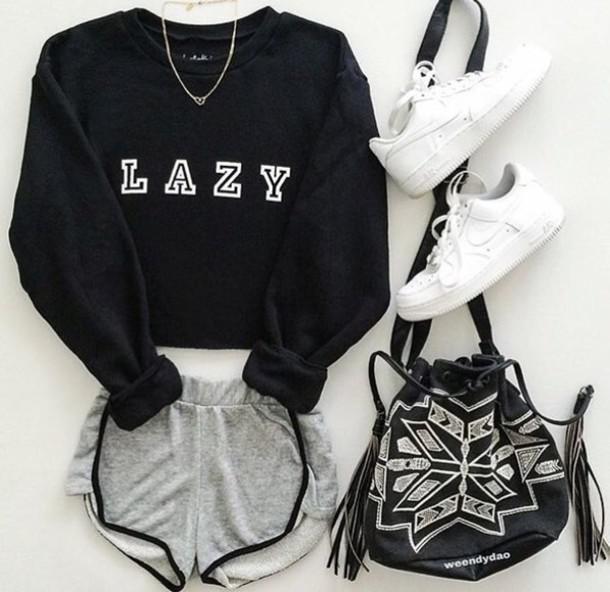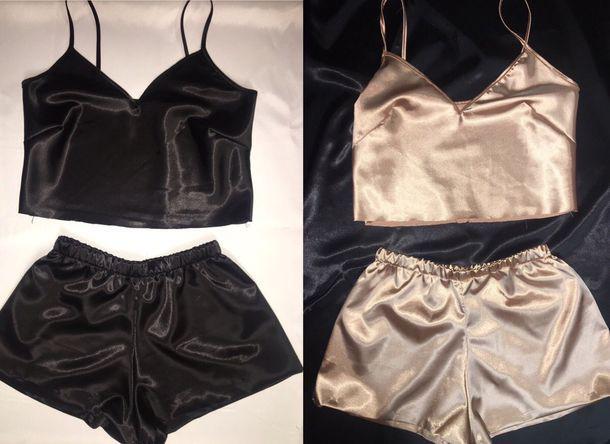The first image is the image on the left, the second image is the image on the right. Given the left and right images, does the statement "There are two sets of female pajamas - one of which is of the color gold." hold true? Answer yes or no. Yes. 